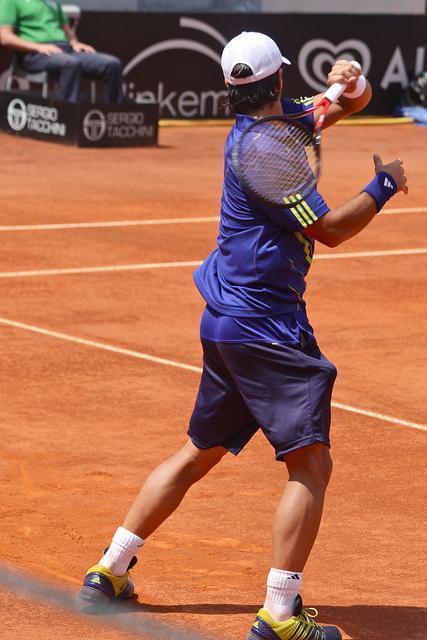What move does this player use?
Pick the correct solution from the four options below to address the question.
Options: Forehand, backhand, serve, lob. Backhand. 